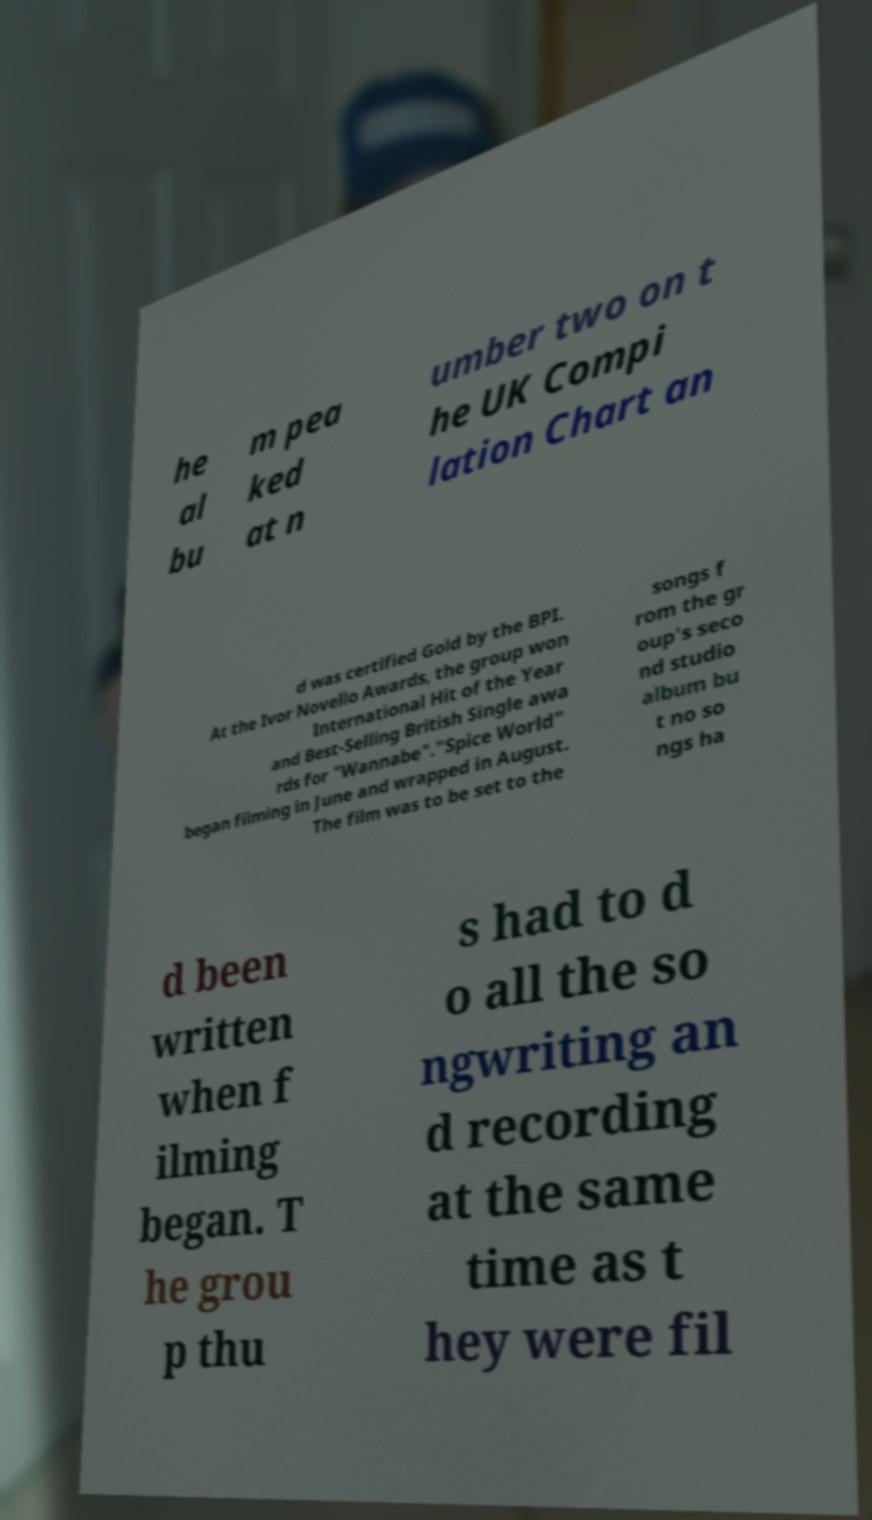For documentation purposes, I need the text within this image transcribed. Could you provide that? he al bu m pea ked at n umber two on t he UK Compi lation Chart an d was certified Gold by the BPI. At the Ivor Novello Awards, the group won International Hit of the Year and Best-Selling British Single awa rds for "Wannabe"."Spice World" began filming in June and wrapped in August. The film was to be set to the songs f rom the gr oup's seco nd studio album bu t no so ngs ha d been written when f ilming began. T he grou p thu s had to d o all the so ngwriting an d recording at the same time as t hey were fil 